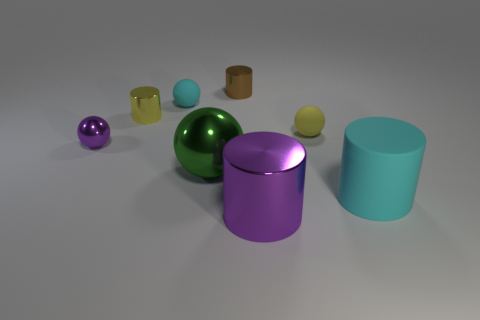Is the material of the purple thing that is right of the brown metal object the same as the cylinder that is to the left of the green thing? The purple object to the right of the brown metal object appears to have a reflective surface similar to the cylindrical object to the left of the green thing, suggesting that they could be made of similar materials, such as a type of metal or plastic with a glossy finish. 